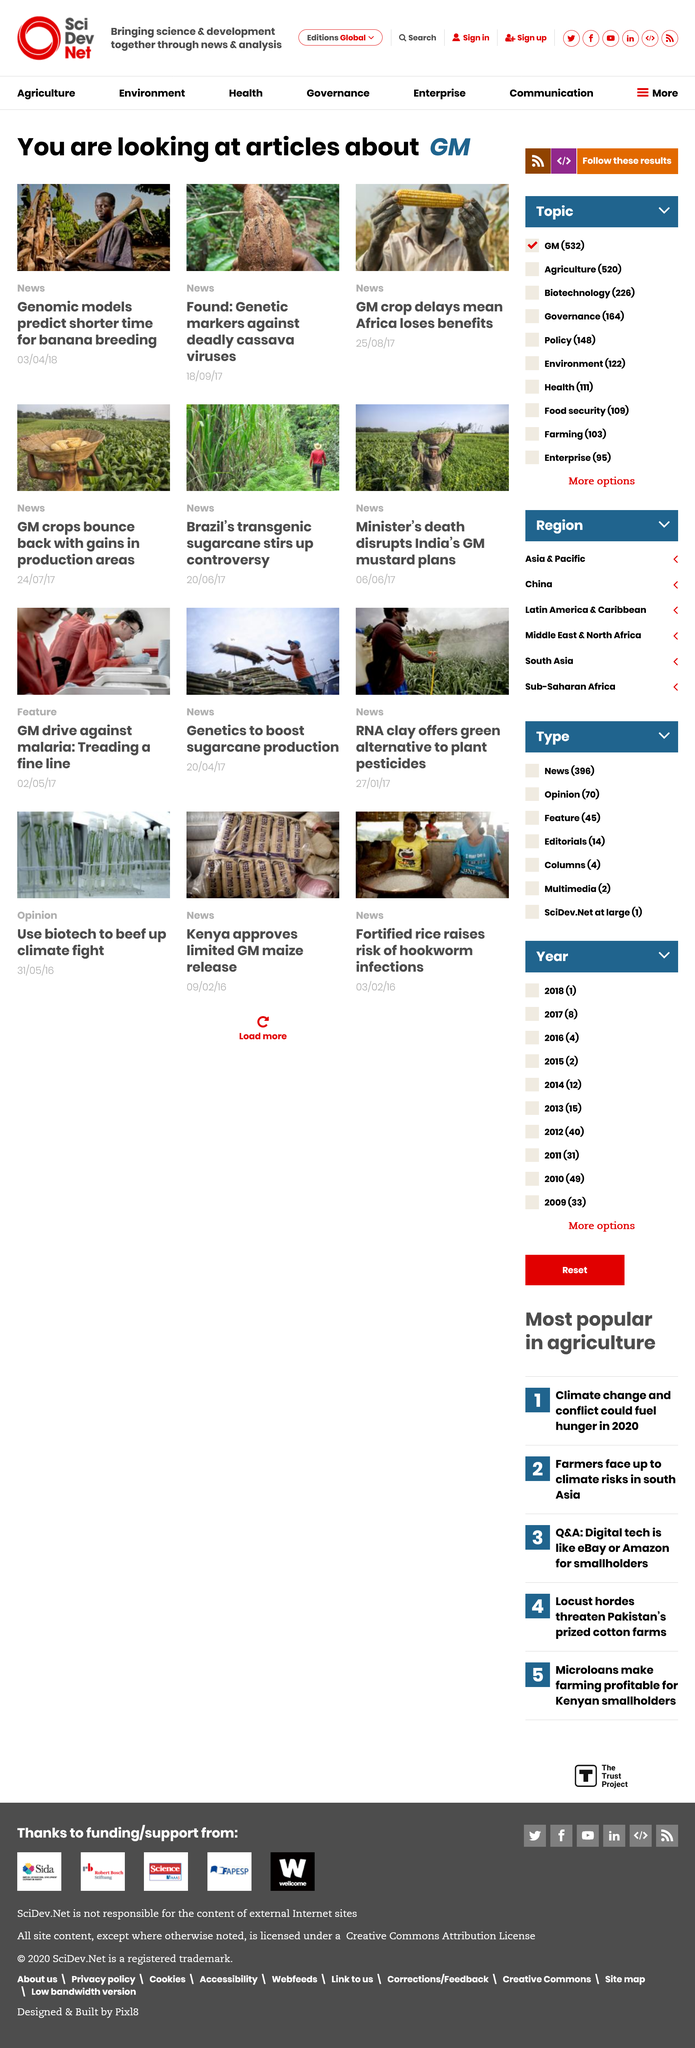Give some essential details in this illustration. The right corner image was taken at an African corn crop, located where. The article about Genomic models predicting a shorter time for banana breeding was published on April 3rd, 2018. The middle image depicts a cassava plant potentially infected with a virus. 